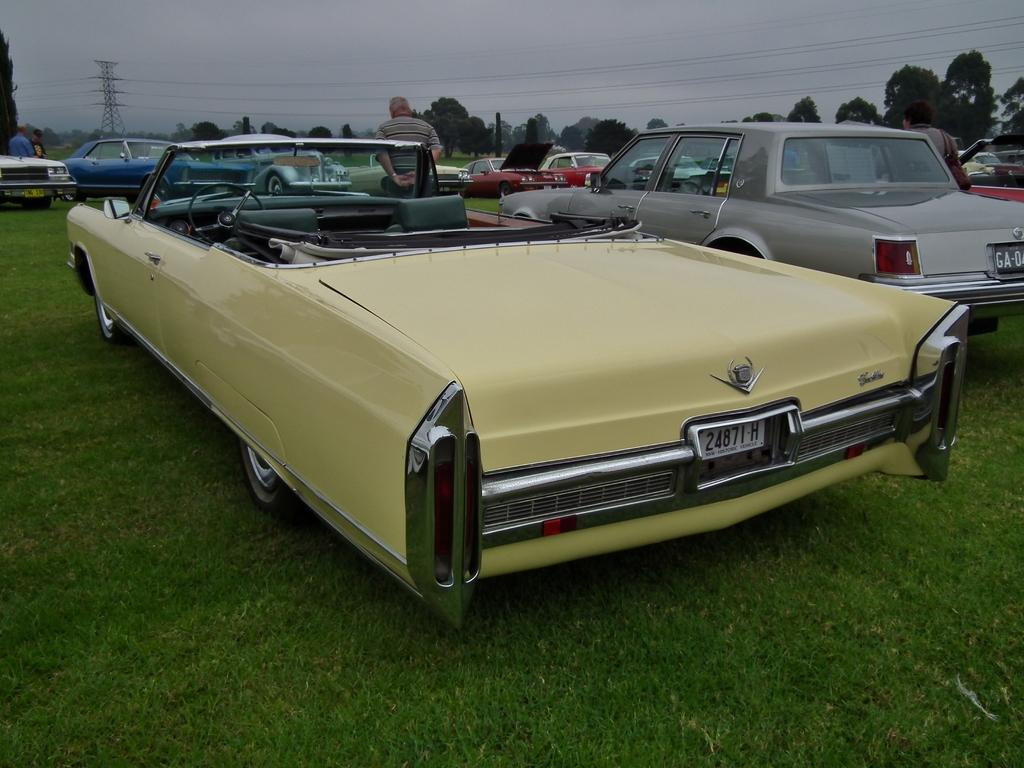What is located on the grass in the image? There are vehicles on the grass in the image. What else can be seen in the image besides the vehicles? There are people standing in the image. What is visible in the background of the image? There are trees, wires, a tower, and clouds in the sky in the background of the image. How many snails are crawling on the tower in the image? There are no snails present in the image; the tower is visible in the background, but no snails are crawling on it. What type of trouble are the people in the image facing? There is no indication of trouble in the image; people are simply standing near the vehicles on the grass. 